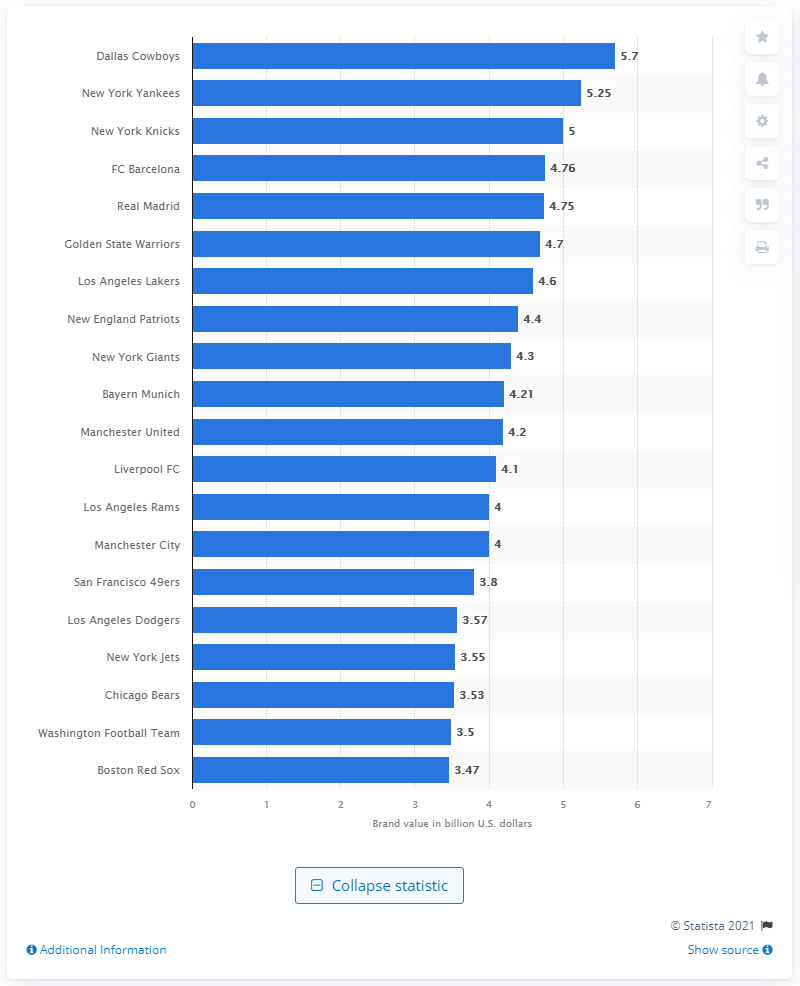Identify some key points in this picture. The estimated value of the Dallas Cowboys in dollars in 2021 was 5.7. The Dallas Cowboys were the most valuable sports team worldwide in 2021. 